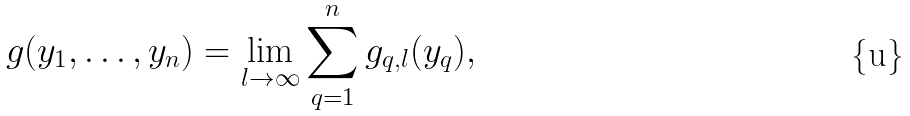Convert formula to latex. <formula><loc_0><loc_0><loc_500><loc_500>g ( y _ { 1 } , \dots , y _ { n } ) = \lim _ { l \to \infty } \sum _ { q = 1 } ^ { n } g _ { q , l } ( y _ { q } ) ,</formula> 